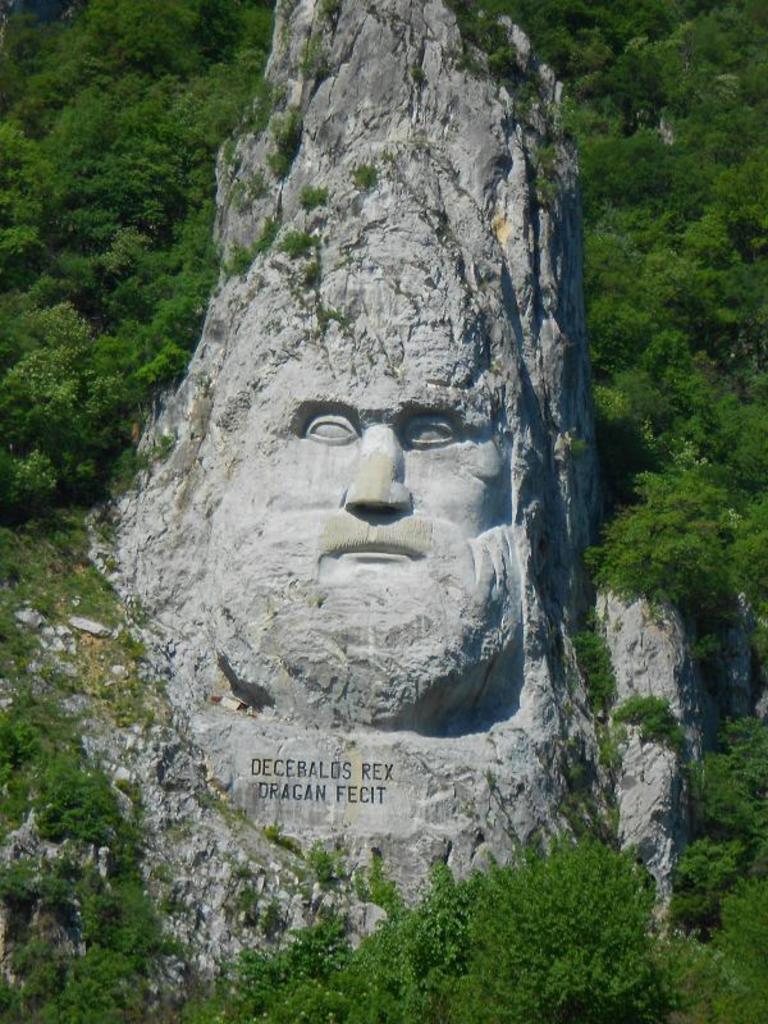How would you summarize this image in a sentence or two? In this image we can see the person sculpture and also the text on the hill. We can also see many trees. 